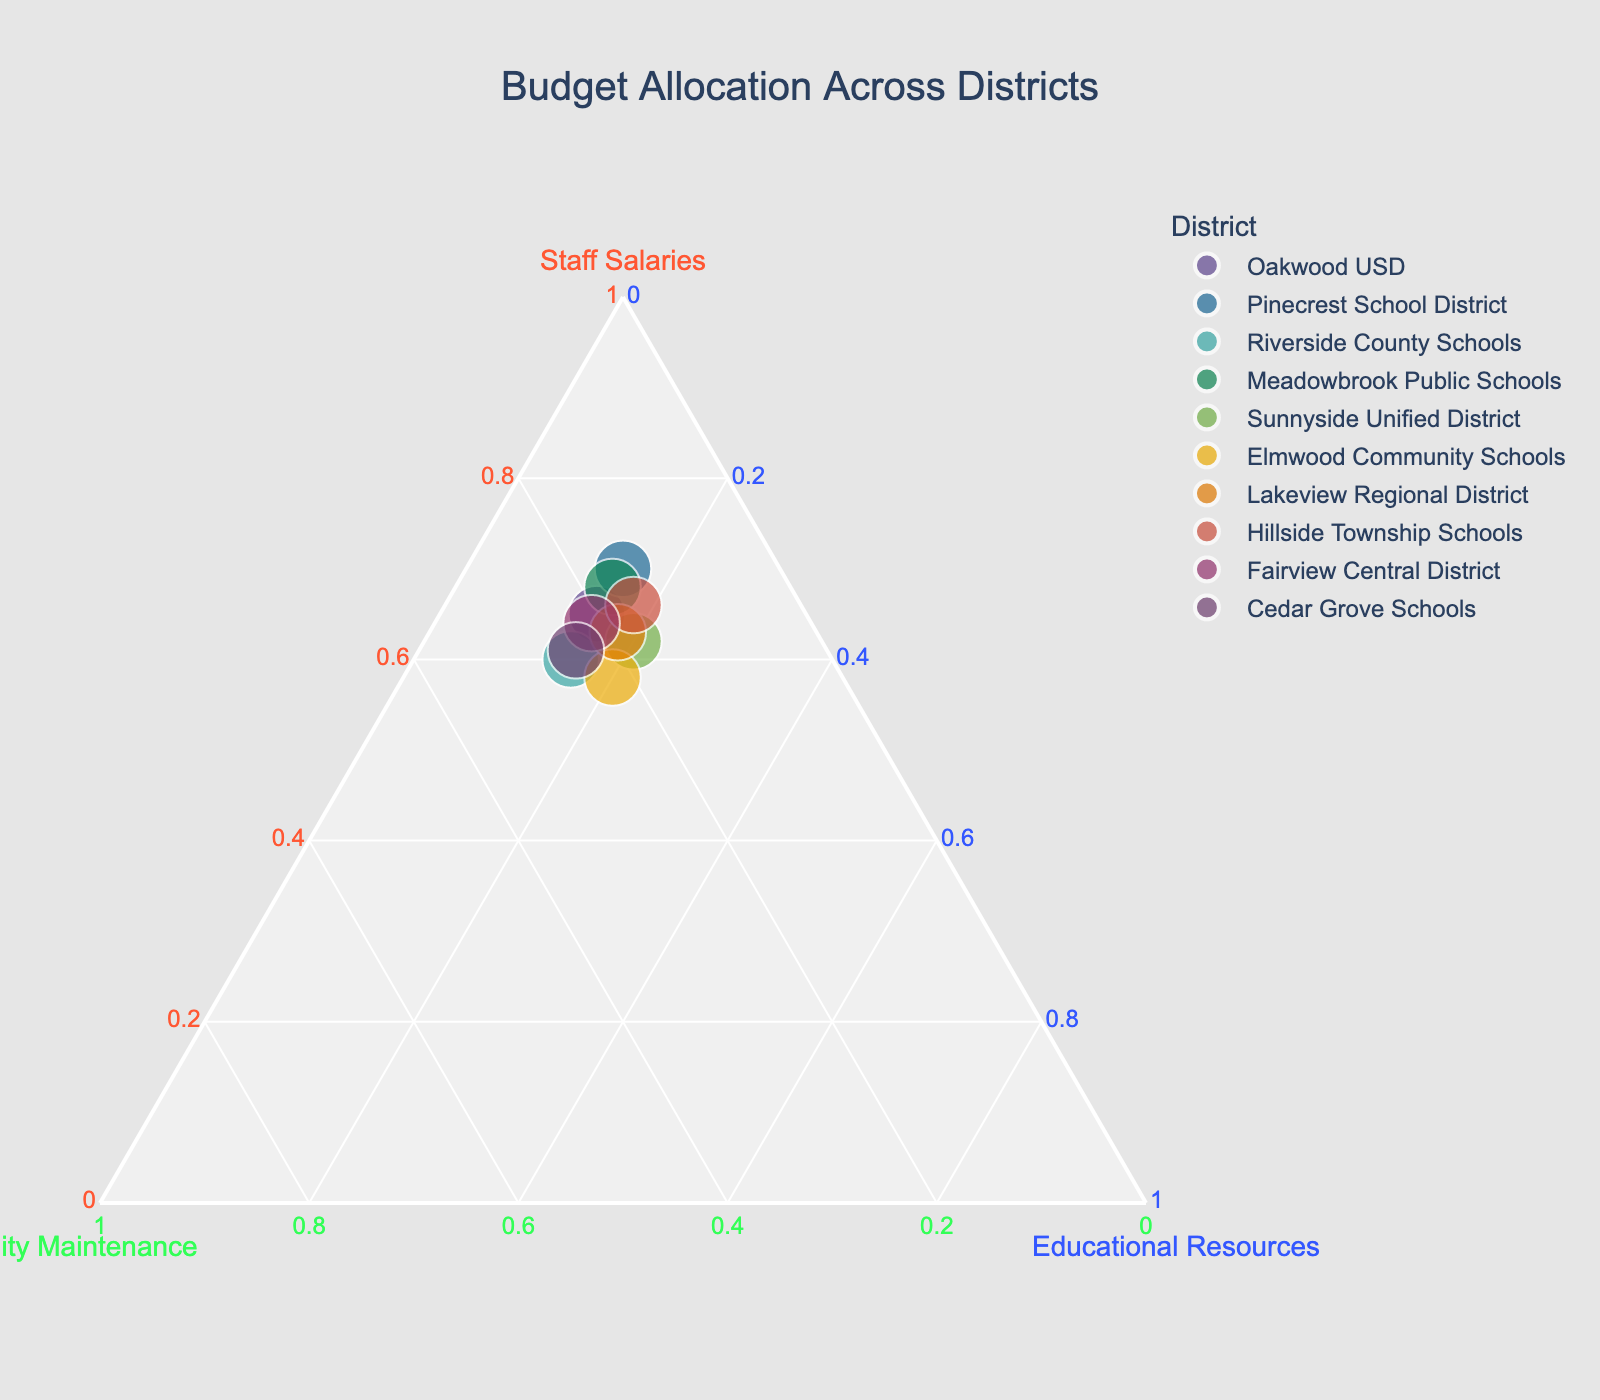What is the title of the figure? The title is typically displayed at the top of the figure. In this case, it is specified in the plotting code.
Answer: Budget Allocation Across Districts How many data points are represented in the plot? There are 10 districts listed in the data table, each corresponding to a point in the plot.
Answer: 10 Which district allocates the highest percentage to staff salaries? The district with the highest staff salaries percentage will be located closest to the "Staff Salaries" axis. Referring to the data, Pinecrest School District allocates 70%.
Answer: Pinecrest School District What is the range of percentages allocated to educational resources across all districts? By checking the 'Educational_Resources' column in the dataset, the minimum is 15% and the maximum is 20%.
Answer: 15% to 20% How many districts allocate at least 20% of their budget to facility maintenance? Points near the 'Facility Maintenance' axis at or above the 20% mark are counted: Riverside County Schools, Cedar Grove Schools, Fairview Central District, and Elmwood Community Schools.
Answer: 4 Which districts allocate exactly 15% to educational resources? By comparing the educational resources allocation, Oakwood USD, Pinecrest School District, Riverside County Schools, Meadowbrook Public Schools, and Fairview Central District all allocate 15%.
Answer: Oakwood USD, Pinecrest School District, Riverside County Schools, Meadowbrook Public Schools, Fairview Central District Does any district allocate more to educational resources than to staff salaries? Compare points along the "Educational Resources" axis to their positions along "Staff Salaries." All points allocate more to staff salaries than to educational resources.
Answer: No Which district has the most balanced allocation among the three categories? The most balanced allocation would be closer to the center of the ternary plot. Lakeview Regional District (63% Staff Salaries, 19% Facility Maintenance, 18% Educational Resources) appears the most balanced.
Answer: Lakeview Regional District Compare Oakwood USD and Hillside Township Schools in terms of facility maintenance allocation. Which allocates a higher percentage? Check the facility maintenance percentages: Oakwood USD (20%) vs. Hillside Township Schools (16%). Oakwood USD allocates more.
Answer: Oakwood USD What is the average allocation to staff salaries across all districts? Sum up all the percentages for staff salaries: (65 + 70 + 60 + 68 + 62 + 58 + 63 + 66 + 64 + 61) = 637. Then, divide by the number of districts, 637/10 = 63.7%.
Answer: 63.7% 